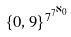Convert formula to latex. <formula><loc_0><loc_0><loc_500><loc_500>\{ 0 , 9 \} ^ { 7 ^ { 7 ^ { \aleph _ { 0 } } } }</formula> 